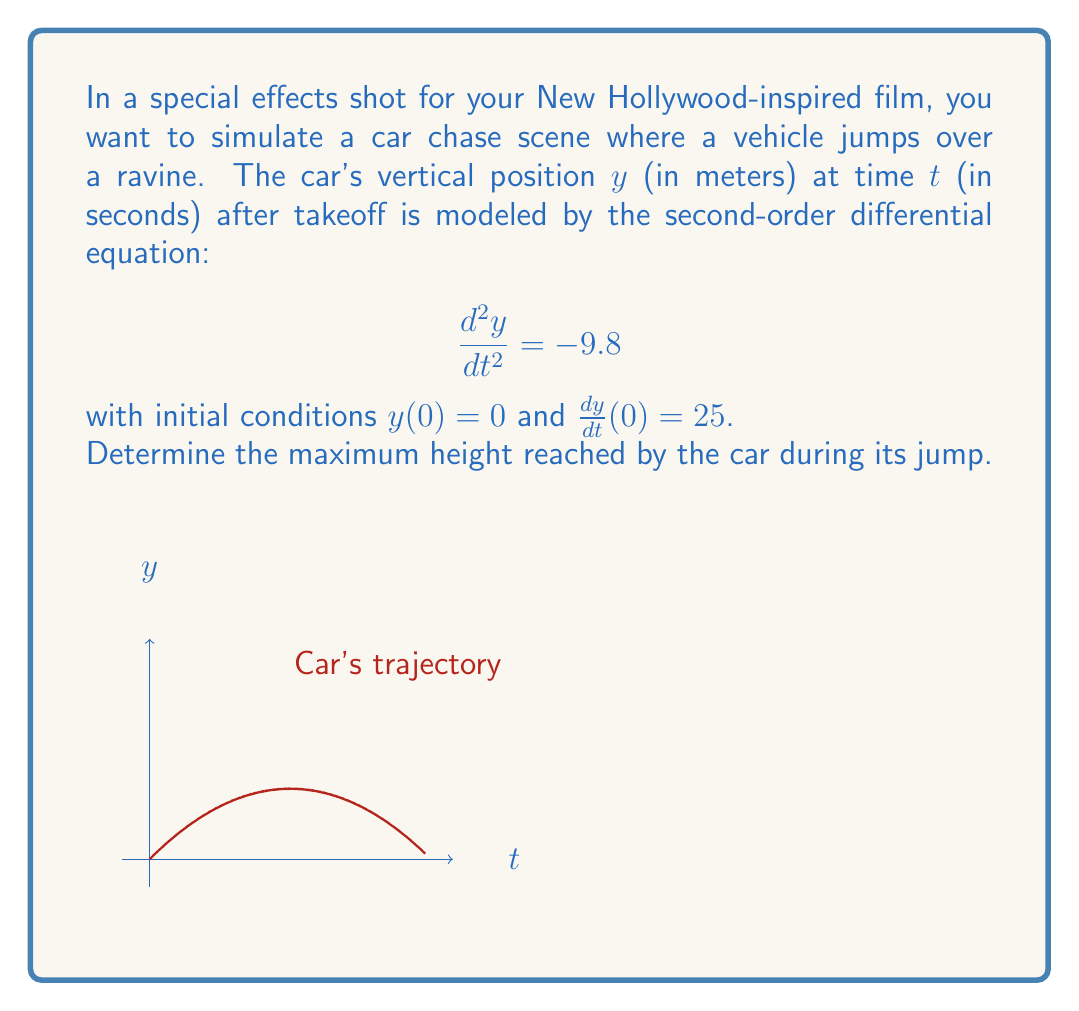Could you help me with this problem? To solve this problem, we'll follow these steps:

1) The given differential equation is:
   $$\frac{d^2y}{dt^2} = -9.8$$

2) Integrate once to get the velocity:
   $$\frac{dy}{dt} = -9.8t + C_1$$
   
   Using the initial condition $\frac{dy}{dt}(0) = 25$, we find $C_1 = 25$.
   
   So, $$\frac{dy}{dt} = -9.8t + 25$$

3) Integrate again to get the position:
   $$y = -4.9t^2 + 25t + C_2$$
   
   Using the initial condition $y(0) = 0$, we find $C_2 = 0$.
   
   Therefore, the position function is:
   $$y = -4.9t^2 + 25t$$

4) To find the maximum height, we need to find where the velocity is zero:
   $$\frac{dy}{dt} = -9.8t + 25 = 0$$
   $$t = \frac{25}{9.8} \approx 2.55 \text{ seconds}$$

5) Substitute this time back into the position function:
   $$y_{max} = -4.9(2.55)^2 + 25(2.55)$$
   $$y_{max} = -31.87 + 63.75 = 31.88 \text{ meters}$$

Thus, the car reaches a maximum height of approximately 31.88 meters.
Answer: 31.88 meters 